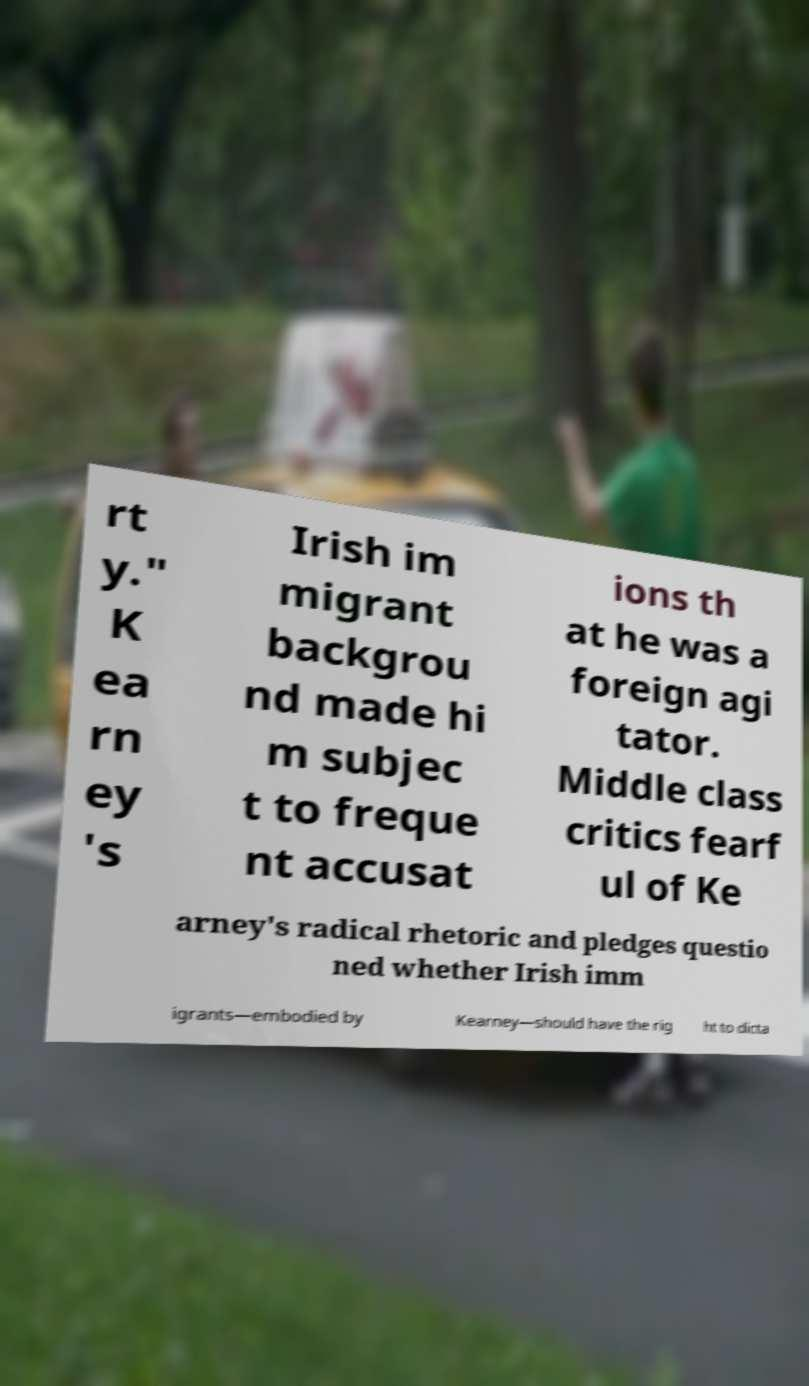What messages or text are displayed in this image? I need them in a readable, typed format. rt y." K ea rn ey 's Irish im migrant backgrou nd made hi m subjec t to freque nt accusat ions th at he was a foreign agi tator. Middle class critics fearf ul of Ke arney's radical rhetoric and pledges questio ned whether Irish imm igrants—embodied by Kearney—should have the rig ht to dicta 